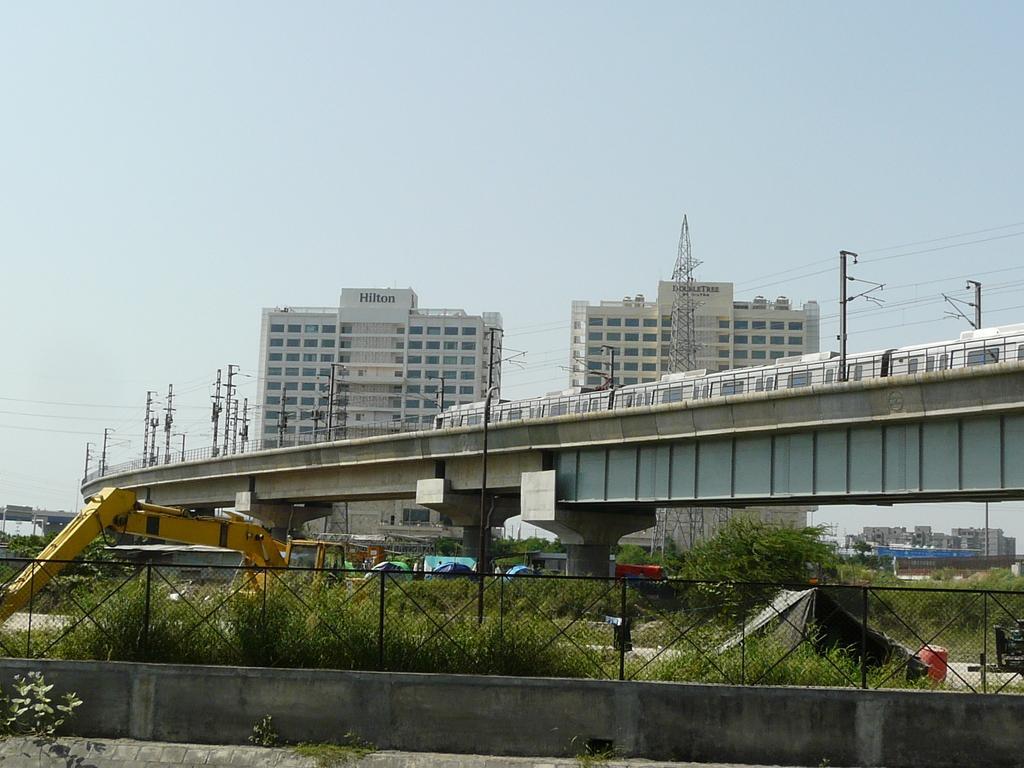Describe this image in one or two sentences. As we can see in the image, in the front there is a fence, plants tree, crane, metro on bridge, two buildings. On the top there is sky. 